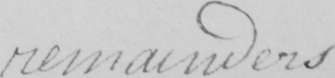Please transcribe the handwritten text in this image. remainders 